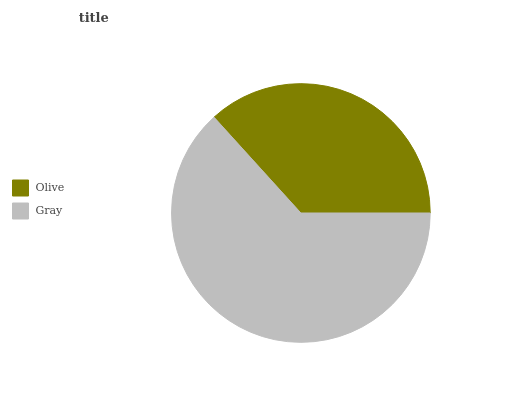Is Olive the minimum?
Answer yes or no. Yes. Is Gray the maximum?
Answer yes or no. Yes. Is Gray the minimum?
Answer yes or no. No. Is Gray greater than Olive?
Answer yes or no. Yes. Is Olive less than Gray?
Answer yes or no. Yes. Is Olive greater than Gray?
Answer yes or no. No. Is Gray less than Olive?
Answer yes or no. No. Is Gray the high median?
Answer yes or no. Yes. Is Olive the low median?
Answer yes or no. Yes. Is Olive the high median?
Answer yes or no. No. Is Gray the low median?
Answer yes or no. No. 